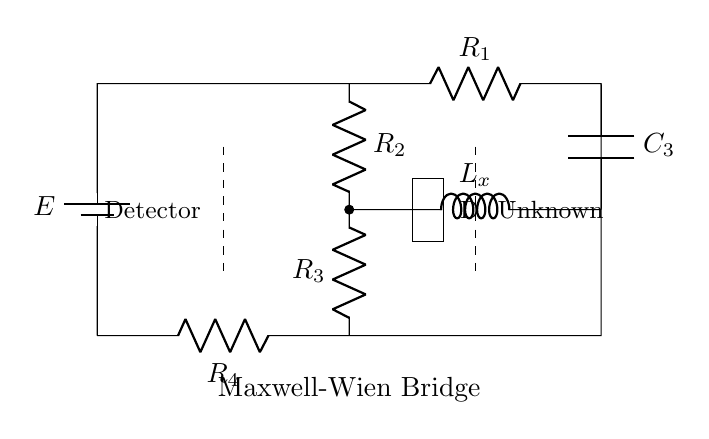What is the type of bridge depicted in the circuit? The circuit shown is a Maxwell-Wien bridge, which is used for measuring inductance accurately. It is a specific type of bridge circuit designed to balance the impedances in a way that facilitates precise inductance measurement.
Answer: Maxwell-Wien bridge What is the component labeled as L_x? L_x refers to the unknown inductance that is to be measured. In the context of a Maxwell-Wien bridge, it is the main component whose value is being determined through the balancing of the bridge.
Answer: Unknown inductance How many resistors are present in this circuit? The circuit contains three resistors: R1, R2, and R3. These resistors are part of the bridge network, which helps in achieving balance for the inductance measurements.
Answer: Three What is the function of the component labeled C_3? C_3 is a capacitor in the circuit that works in conjunction with the inductance and resistors to create an impedance balance condition necessary for accurate measurements. It helps in achieving the correct phase relationship in the bridge.
Answer: Capacitor What does the dashed line signify in this diagram? The dashed lines typically indicate an area of measurement or a boundary where the detector and unknown component are separated from the rest of the circuit, showing that these parts are not directly connected in this context but are elements of the measurement setup.
Answer: Measurement indication What role does the battery play in this circuit? The battery provides the necessary voltage supply to the circuit, enabling current to flow through the components and allowing for the operation of the bridge in measuring inductance.
Answer: Voltage supply 